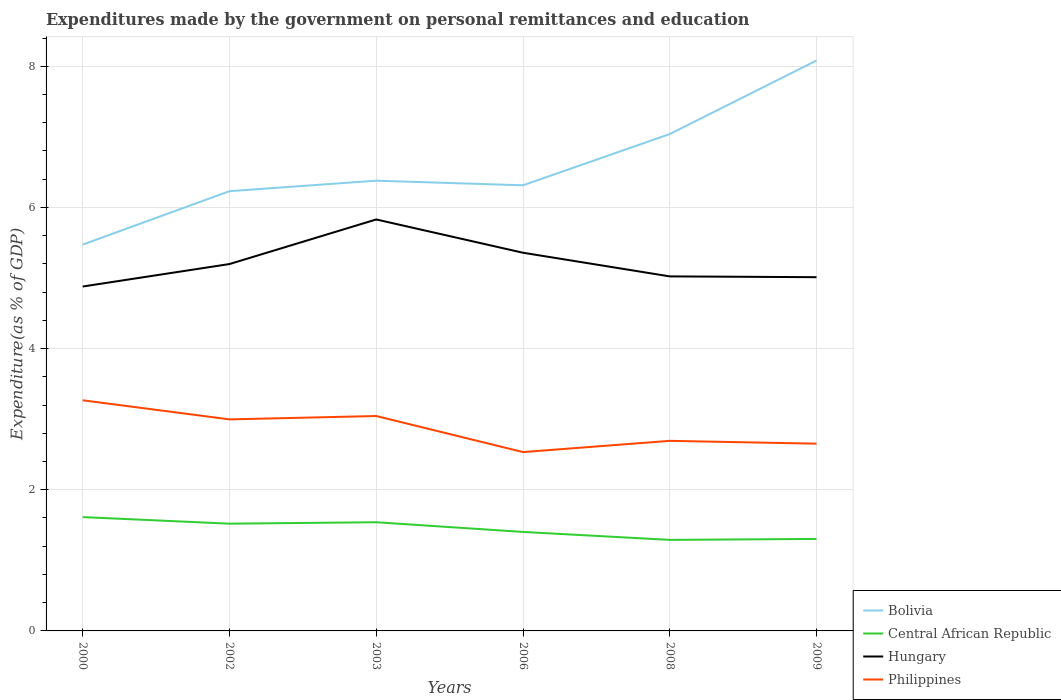Does the line corresponding to Philippines intersect with the line corresponding to Hungary?
Provide a succinct answer. No. Across all years, what is the maximum expenditures made by the government on personal remittances and education in Bolivia?
Your answer should be compact. 5.47. What is the total expenditures made by the government on personal remittances and education in Central African Republic in the graph?
Offer a very short reply. 0.31. What is the difference between the highest and the second highest expenditures made by the government on personal remittances and education in Central African Republic?
Give a very brief answer. 0.32. Is the expenditures made by the government on personal remittances and education in Central African Republic strictly greater than the expenditures made by the government on personal remittances and education in Bolivia over the years?
Offer a very short reply. Yes. How many lines are there?
Keep it short and to the point. 4. How many legend labels are there?
Your answer should be very brief. 4. What is the title of the graph?
Offer a very short reply. Expenditures made by the government on personal remittances and education. Does "Least developed countries" appear as one of the legend labels in the graph?
Offer a terse response. No. What is the label or title of the X-axis?
Offer a very short reply. Years. What is the label or title of the Y-axis?
Your answer should be compact. Expenditure(as % of GDP). What is the Expenditure(as % of GDP) of Bolivia in 2000?
Provide a short and direct response. 5.47. What is the Expenditure(as % of GDP) in Central African Republic in 2000?
Offer a terse response. 1.61. What is the Expenditure(as % of GDP) in Hungary in 2000?
Offer a very short reply. 4.88. What is the Expenditure(as % of GDP) in Philippines in 2000?
Your answer should be compact. 3.27. What is the Expenditure(as % of GDP) of Bolivia in 2002?
Keep it short and to the point. 6.23. What is the Expenditure(as % of GDP) of Central African Republic in 2002?
Give a very brief answer. 1.52. What is the Expenditure(as % of GDP) in Hungary in 2002?
Ensure brevity in your answer.  5.2. What is the Expenditure(as % of GDP) of Philippines in 2002?
Give a very brief answer. 3. What is the Expenditure(as % of GDP) of Bolivia in 2003?
Give a very brief answer. 6.38. What is the Expenditure(as % of GDP) of Central African Republic in 2003?
Your answer should be compact. 1.54. What is the Expenditure(as % of GDP) in Hungary in 2003?
Your answer should be very brief. 5.83. What is the Expenditure(as % of GDP) in Philippines in 2003?
Offer a very short reply. 3.04. What is the Expenditure(as % of GDP) in Bolivia in 2006?
Make the answer very short. 6.31. What is the Expenditure(as % of GDP) of Central African Republic in 2006?
Keep it short and to the point. 1.4. What is the Expenditure(as % of GDP) in Hungary in 2006?
Offer a terse response. 5.36. What is the Expenditure(as % of GDP) of Philippines in 2006?
Offer a terse response. 2.53. What is the Expenditure(as % of GDP) in Bolivia in 2008?
Ensure brevity in your answer.  7.04. What is the Expenditure(as % of GDP) of Central African Republic in 2008?
Give a very brief answer. 1.29. What is the Expenditure(as % of GDP) of Hungary in 2008?
Ensure brevity in your answer.  5.02. What is the Expenditure(as % of GDP) in Philippines in 2008?
Give a very brief answer. 2.69. What is the Expenditure(as % of GDP) of Bolivia in 2009?
Ensure brevity in your answer.  8.08. What is the Expenditure(as % of GDP) of Central African Republic in 2009?
Your answer should be very brief. 1.3. What is the Expenditure(as % of GDP) in Hungary in 2009?
Your answer should be very brief. 5.01. What is the Expenditure(as % of GDP) in Philippines in 2009?
Keep it short and to the point. 2.65. Across all years, what is the maximum Expenditure(as % of GDP) of Bolivia?
Ensure brevity in your answer.  8.08. Across all years, what is the maximum Expenditure(as % of GDP) of Central African Republic?
Your answer should be very brief. 1.61. Across all years, what is the maximum Expenditure(as % of GDP) in Hungary?
Your answer should be very brief. 5.83. Across all years, what is the maximum Expenditure(as % of GDP) of Philippines?
Offer a very short reply. 3.27. Across all years, what is the minimum Expenditure(as % of GDP) of Bolivia?
Provide a short and direct response. 5.47. Across all years, what is the minimum Expenditure(as % of GDP) in Central African Republic?
Ensure brevity in your answer.  1.29. Across all years, what is the minimum Expenditure(as % of GDP) of Hungary?
Make the answer very short. 4.88. Across all years, what is the minimum Expenditure(as % of GDP) of Philippines?
Provide a short and direct response. 2.53. What is the total Expenditure(as % of GDP) in Bolivia in the graph?
Offer a very short reply. 39.52. What is the total Expenditure(as % of GDP) in Central African Republic in the graph?
Your answer should be very brief. 8.67. What is the total Expenditure(as % of GDP) in Hungary in the graph?
Your answer should be compact. 31.3. What is the total Expenditure(as % of GDP) in Philippines in the graph?
Give a very brief answer. 17.19. What is the difference between the Expenditure(as % of GDP) in Bolivia in 2000 and that in 2002?
Your response must be concise. -0.76. What is the difference between the Expenditure(as % of GDP) of Central African Republic in 2000 and that in 2002?
Your response must be concise. 0.09. What is the difference between the Expenditure(as % of GDP) in Hungary in 2000 and that in 2002?
Provide a short and direct response. -0.32. What is the difference between the Expenditure(as % of GDP) in Philippines in 2000 and that in 2002?
Provide a short and direct response. 0.27. What is the difference between the Expenditure(as % of GDP) of Bolivia in 2000 and that in 2003?
Your response must be concise. -0.91. What is the difference between the Expenditure(as % of GDP) in Central African Republic in 2000 and that in 2003?
Provide a succinct answer. 0.07. What is the difference between the Expenditure(as % of GDP) of Hungary in 2000 and that in 2003?
Your answer should be compact. -0.95. What is the difference between the Expenditure(as % of GDP) in Philippines in 2000 and that in 2003?
Make the answer very short. 0.22. What is the difference between the Expenditure(as % of GDP) in Bolivia in 2000 and that in 2006?
Offer a very short reply. -0.84. What is the difference between the Expenditure(as % of GDP) in Central African Republic in 2000 and that in 2006?
Provide a succinct answer. 0.21. What is the difference between the Expenditure(as % of GDP) in Hungary in 2000 and that in 2006?
Make the answer very short. -0.48. What is the difference between the Expenditure(as % of GDP) of Philippines in 2000 and that in 2006?
Your response must be concise. 0.73. What is the difference between the Expenditure(as % of GDP) of Bolivia in 2000 and that in 2008?
Ensure brevity in your answer.  -1.57. What is the difference between the Expenditure(as % of GDP) in Central African Republic in 2000 and that in 2008?
Offer a very short reply. 0.32. What is the difference between the Expenditure(as % of GDP) in Hungary in 2000 and that in 2008?
Provide a short and direct response. -0.14. What is the difference between the Expenditure(as % of GDP) in Philippines in 2000 and that in 2008?
Provide a succinct answer. 0.57. What is the difference between the Expenditure(as % of GDP) in Bolivia in 2000 and that in 2009?
Provide a succinct answer. -2.61. What is the difference between the Expenditure(as % of GDP) of Central African Republic in 2000 and that in 2009?
Ensure brevity in your answer.  0.31. What is the difference between the Expenditure(as % of GDP) in Hungary in 2000 and that in 2009?
Provide a succinct answer. -0.13. What is the difference between the Expenditure(as % of GDP) of Philippines in 2000 and that in 2009?
Your response must be concise. 0.61. What is the difference between the Expenditure(as % of GDP) of Bolivia in 2002 and that in 2003?
Your response must be concise. -0.15. What is the difference between the Expenditure(as % of GDP) of Central African Republic in 2002 and that in 2003?
Your answer should be very brief. -0.02. What is the difference between the Expenditure(as % of GDP) in Hungary in 2002 and that in 2003?
Your answer should be very brief. -0.63. What is the difference between the Expenditure(as % of GDP) of Philippines in 2002 and that in 2003?
Your answer should be compact. -0.05. What is the difference between the Expenditure(as % of GDP) in Bolivia in 2002 and that in 2006?
Your response must be concise. -0.08. What is the difference between the Expenditure(as % of GDP) in Central African Republic in 2002 and that in 2006?
Give a very brief answer. 0.12. What is the difference between the Expenditure(as % of GDP) in Hungary in 2002 and that in 2006?
Your answer should be compact. -0.16. What is the difference between the Expenditure(as % of GDP) of Philippines in 2002 and that in 2006?
Give a very brief answer. 0.46. What is the difference between the Expenditure(as % of GDP) of Bolivia in 2002 and that in 2008?
Provide a short and direct response. -0.81. What is the difference between the Expenditure(as % of GDP) in Central African Republic in 2002 and that in 2008?
Offer a very short reply. 0.23. What is the difference between the Expenditure(as % of GDP) in Hungary in 2002 and that in 2008?
Offer a terse response. 0.17. What is the difference between the Expenditure(as % of GDP) in Philippines in 2002 and that in 2008?
Make the answer very short. 0.3. What is the difference between the Expenditure(as % of GDP) in Bolivia in 2002 and that in 2009?
Ensure brevity in your answer.  -1.85. What is the difference between the Expenditure(as % of GDP) in Central African Republic in 2002 and that in 2009?
Provide a short and direct response. 0.22. What is the difference between the Expenditure(as % of GDP) of Hungary in 2002 and that in 2009?
Provide a short and direct response. 0.19. What is the difference between the Expenditure(as % of GDP) in Philippines in 2002 and that in 2009?
Give a very brief answer. 0.34. What is the difference between the Expenditure(as % of GDP) in Bolivia in 2003 and that in 2006?
Keep it short and to the point. 0.07. What is the difference between the Expenditure(as % of GDP) of Central African Republic in 2003 and that in 2006?
Make the answer very short. 0.14. What is the difference between the Expenditure(as % of GDP) in Hungary in 2003 and that in 2006?
Provide a short and direct response. 0.47. What is the difference between the Expenditure(as % of GDP) of Philippines in 2003 and that in 2006?
Make the answer very short. 0.51. What is the difference between the Expenditure(as % of GDP) in Bolivia in 2003 and that in 2008?
Offer a very short reply. -0.66. What is the difference between the Expenditure(as % of GDP) in Central African Republic in 2003 and that in 2008?
Your answer should be compact. 0.25. What is the difference between the Expenditure(as % of GDP) in Hungary in 2003 and that in 2008?
Your answer should be compact. 0.81. What is the difference between the Expenditure(as % of GDP) in Philippines in 2003 and that in 2008?
Offer a terse response. 0.35. What is the difference between the Expenditure(as % of GDP) of Bolivia in 2003 and that in 2009?
Keep it short and to the point. -1.7. What is the difference between the Expenditure(as % of GDP) in Central African Republic in 2003 and that in 2009?
Your answer should be compact. 0.24. What is the difference between the Expenditure(as % of GDP) of Hungary in 2003 and that in 2009?
Give a very brief answer. 0.82. What is the difference between the Expenditure(as % of GDP) in Philippines in 2003 and that in 2009?
Make the answer very short. 0.39. What is the difference between the Expenditure(as % of GDP) in Bolivia in 2006 and that in 2008?
Ensure brevity in your answer.  -0.73. What is the difference between the Expenditure(as % of GDP) of Central African Republic in 2006 and that in 2008?
Keep it short and to the point. 0.11. What is the difference between the Expenditure(as % of GDP) of Hungary in 2006 and that in 2008?
Ensure brevity in your answer.  0.34. What is the difference between the Expenditure(as % of GDP) in Philippines in 2006 and that in 2008?
Offer a very short reply. -0.16. What is the difference between the Expenditure(as % of GDP) of Bolivia in 2006 and that in 2009?
Ensure brevity in your answer.  -1.77. What is the difference between the Expenditure(as % of GDP) of Central African Republic in 2006 and that in 2009?
Ensure brevity in your answer.  0.1. What is the difference between the Expenditure(as % of GDP) in Hungary in 2006 and that in 2009?
Your answer should be very brief. 0.35. What is the difference between the Expenditure(as % of GDP) in Philippines in 2006 and that in 2009?
Provide a short and direct response. -0.12. What is the difference between the Expenditure(as % of GDP) in Bolivia in 2008 and that in 2009?
Offer a terse response. -1.04. What is the difference between the Expenditure(as % of GDP) of Central African Republic in 2008 and that in 2009?
Ensure brevity in your answer.  -0.01. What is the difference between the Expenditure(as % of GDP) in Hungary in 2008 and that in 2009?
Your answer should be compact. 0.01. What is the difference between the Expenditure(as % of GDP) in Bolivia in 2000 and the Expenditure(as % of GDP) in Central African Republic in 2002?
Offer a terse response. 3.95. What is the difference between the Expenditure(as % of GDP) in Bolivia in 2000 and the Expenditure(as % of GDP) in Hungary in 2002?
Provide a short and direct response. 0.28. What is the difference between the Expenditure(as % of GDP) in Bolivia in 2000 and the Expenditure(as % of GDP) in Philippines in 2002?
Give a very brief answer. 2.48. What is the difference between the Expenditure(as % of GDP) of Central African Republic in 2000 and the Expenditure(as % of GDP) of Hungary in 2002?
Your answer should be compact. -3.59. What is the difference between the Expenditure(as % of GDP) in Central African Republic in 2000 and the Expenditure(as % of GDP) in Philippines in 2002?
Offer a very short reply. -1.38. What is the difference between the Expenditure(as % of GDP) of Hungary in 2000 and the Expenditure(as % of GDP) of Philippines in 2002?
Your answer should be very brief. 1.88. What is the difference between the Expenditure(as % of GDP) in Bolivia in 2000 and the Expenditure(as % of GDP) in Central African Republic in 2003?
Offer a very short reply. 3.93. What is the difference between the Expenditure(as % of GDP) of Bolivia in 2000 and the Expenditure(as % of GDP) of Hungary in 2003?
Offer a terse response. -0.36. What is the difference between the Expenditure(as % of GDP) in Bolivia in 2000 and the Expenditure(as % of GDP) in Philippines in 2003?
Your response must be concise. 2.43. What is the difference between the Expenditure(as % of GDP) of Central African Republic in 2000 and the Expenditure(as % of GDP) of Hungary in 2003?
Provide a succinct answer. -4.22. What is the difference between the Expenditure(as % of GDP) of Central African Republic in 2000 and the Expenditure(as % of GDP) of Philippines in 2003?
Your response must be concise. -1.43. What is the difference between the Expenditure(as % of GDP) in Hungary in 2000 and the Expenditure(as % of GDP) in Philippines in 2003?
Provide a succinct answer. 1.83. What is the difference between the Expenditure(as % of GDP) in Bolivia in 2000 and the Expenditure(as % of GDP) in Central African Republic in 2006?
Make the answer very short. 4.07. What is the difference between the Expenditure(as % of GDP) of Bolivia in 2000 and the Expenditure(as % of GDP) of Hungary in 2006?
Your answer should be compact. 0.12. What is the difference between the Expenditure(as % of GDP) of Bolivia in 2000 and the Expenditure(as % of GDP) of Philippines in 2006?
Provide a short and direct response. 2.94. What is the difference between the Expenditure(as % of GDP) in Central African Republic in 2000 and the Expenditure(as % of GDP) in Hungary in 2006?
Offer a terse response. -3.75. What is the difference between the Expenditure(as % of GDP) of Central African Republic in 2000 and the Expenditure(as % of GDP) of Philippines in 2006?
Your answer should be compact. -0.92. What is the difference between the Expenditure(as % of GDP) in Hungary in 2000 and the Expenditure(as % of GDP) in Philippines in 2006?
Your answer should be compact. 2.35. What is the difference between the Expenditure(as % of GDP) in Bolivia in 2000 and the Expenditure(as % of GDP) in Central African Republic in 2008?
Offer a very short reply. 4.18. What is the difference between the Expenditure(as % of GDP) of Bolivia in 2000 and the Expenditure(as % of GDP) of Hungary in 2008?
Give a very brief answer. 0.45. What is the difference between the Expenditure(as % of GDP) of Bolivia in 2000 and the Expenditure(as % of GDP) of Philippines in 2008?
Your response must be concise. 2.78. What is the difference between the Expenditure(as % of GDP) of Central African Republic in 2000 and the Expenditure(as % of GDP) of Hungary in 2008?
Make the answer very short. -3.41. What is the difference between the Expenditure(as % of GDP) in Central African Republic in 2000 and the Expenditure(as % of GDP) in Philippines in 2008?
Your answer should be compact. -1.08. What is the difference between the Expenditure(as % of GDP) of Hungary in 2000 and the Expenditure(as % of GDP) of Philippines in 2008?
Offer a very short reply. 2.19. What is the difference between the Expenditure(as % of GDP) in Bolivia in 2000 and the Expenditure(as % of GDP) in Central African Republic in 2009?
Keep it short and to the point. 4.17. What is the difference between the Expenditure(as % of GDP) in Bolivia in 2000 and the Expenditure(as % of GDP) in Hungary in 2009?
Give a very brief answer. 0.46. What is the difference between the Expenditure(as % of GDP) of Bolivia in 2000 and the Expenditure(as % of GDP) of Philippines in 2009?
Offer a terse response. 2.82. What is the difference between the Expenditure(as % of GDP) in Central African Republic in 2000 and the Expenditure(as % of GDP) in Hungary in 2009?
Your response must be concise. -3.4. What is the difference between the Expenditure(as % of GDP) of Central African Republic in 2000 and the Expenditure(as % of GDP) of Philippines in 2009?
Ensure brevity in your answer.  -1.04. What is the difference between the Expenditure(as % of GDP) in Hungary in 2000 and the Expenditure(as % of GDP) in Philippines in 2009?
Provide a short and direct response. 2.23. What is the difference between the Expenditure(as % of GDP) in Bolivia in 2002 and the Expenditure(as % of GDP) in Central African Republic in 2003?
Make the answer very short. 4.69. What is the difference between the Expenditure(as % of GDP) of Bolivia in 2002 and the Expenditure(as % of GDP) of Hungary in 2003?
Give a very brief answer. 0.4. What is the difference between the Expenditure(as % of GDP) of Bolivia in 2002 and the Expenditure(as % of GDP) of Philippines in 2003?
Your response must be concise. 3.19. What is the difference between the Expenditure(as % of GDP) in Central African Republic in 2002 and the Expenditure(as % of GDP) in Hungary in 2003?
Offer a terse response. -4.31. What is the difference between the Expenditure(as % of GDP) in Central African Republic in 2002 and the Expenditure(as % of GDP) in Philippines in 2003?
Provide a short and direct response. -1.53. What is the difference between the Expenditure(as % of GDP) in Hungary in 2002 and the Expenditure(as % of GDP) in Philippines in 2003?
Offer a very short reply. 2.15. What is the difference between the Expenditure(as % of GDP) of Bolivia in 2002 and the Expenditure(as % of GDP) of Central African Republic in 2006?
Your answer should be compact. 4.83. What is the difference between the Expenditure(as % of GDP) in Bolivia in 2002 and the Expenditure(as % of GDP) in Hungary in 2006?
Ensure brevity in your answer.  0.87. What is the difference between the Expenditure(as % of GDP) of Bolivia in 2002 and the Expenditure(as % of GDP) of Philippines in 2006?
Keep it short and to the point. 3.7. What is the difference between the Expenditure(as % of GDP) of Central African Republic in 2002 and the Expenditure(as % of GDP) of Hungary in 2006?
Your answer should be very brief. -3.84. What is the difference between the Expenditure(as % of GDP) of Central African Republic in 2002 and the Expenditure(as % of GDP) of Philippines in 2006?
Your answer should be very brief. -1.01. What is the difference between the Expenditure(as % of GDP) of Hungary in 2002 and the Expenditure(as % of GDP) of Philippines in 2006?
Provide a short and direct response. 2.66. What is the difference between the Expenditure(as % of GDP) in Bolivia in 2002 and the Expenditure(as % of GDP) in Central African Republic in 2008?
Provide a succinct answer. 4.94. What is the difference between the Expenditure(as % of GDP) in Bolivia in 2002 and the Expenditure(as % of GDP) in Hungary in 2008?
Your answer should be compact. 1.21. What is the difference between the Expenditure(as % of GDP) in Bolivia in 2002 and the Expenditure(as % of GDP) in Philippines in 2008?
Your answer should be compact. 3.54. What is the difference between the Expenditure(as % of GDP) in Central African Republic in 2002 and the Expenditure(as % of GDP) in Hungary in 2008?
Provide a succinct answer. -3.5. What is the difference between the Expenditure(as % of GDP) in Central African Republic in 2002 and the Expenditure(as % of GDP) in Philippines in 2008?
Provide a succinct answer. -1.17. What is the difference between the Expenditure(as % of GDP) of Hungary in 2002 and the Expenditure(as % of GDP) of Philippines in 2008?
Your answer should be compact. 2.5. What is the difference between the Expenditure(as % of GDP) of Bolivia in 2002 and the Expenditure(as % of GDP) of Central African Republic in 2009?
Offer a terse response. 4.93. What is the difference between the Expenditure(as % of GDP) in Bolivia in 2002 and the Expenditure(as % of GDP) in Hungary in 2009?
Make the answer very short. 1.22. What is the difference between the Expenditure(as % of GDP) in Bolivia in 2002 and the Expenditure(as % of GDP) in Philippines in 2009?
Provide a succinct answer. 3.58. What is the difference between the Expenditure(as % of GDP) of Central African Republic in 2002 and the Expenditure(as % of GDP) of Hungary in 2009?
Your answer should be very brief. -3.49. What is the difference between the Expenditure(as % of GDP) in Central African Republic in 2002 and the Expenditure(as % of GDP) in Philippines in 2009?
Keep it short and to the point. -1.13. What is the difference between the Expenditure(as % of GDP) in Hungary in 2002 and the Expenditure(as % of GDP) in Philippines in 2009?
Your answer should be very brief. 2.54. What is the difference between the Expenditure(as % of GDP) of Bolivia in 2003 and the Expenditure(as % of GDP) of Central African Republic in 2006?
Your answer should be compact. 4.98. What is the difference between the Expenditure(as % of GDP) in Bolivia in 2003 and the Expenditure(as % of GDP) in Hungary in 2006?
Provide a short and direct response. 1.02. What is the difference between the Expenditure(as % of GDP) of Bolivia in 2003 and the Expenditure(as % of GDP) of Philippines in 2006?
Your answer should be compact. 3.85. What is the difference between the Expenditure(as % of GDP) in Central African Republic in 2003 and the Expenditure(as % of GDP) in Hungary in 2006?
Make the answer very short. -3.82. What is the difference between the Expenditure(as % of GDP) of Central African Republic in 2003 and the Expenditure(as % of GDP) of Philippines in 2006?
Make the answer very short. -0.99. What is the difference between the Expenditure(as % of GDP) of Hungary in 2003 and the Expenditure(as % of GDP) of Philippines in 2006?
Keep it short and to the point. 3.3. What is the difference between the Expenditure(as % of GDP) of Bolivia in 2003 and the Expenditure(as % of GDP) of Central African Republic in 2008?
Make the answer very short. 5.09. What is the difference between the Expenditure(as % of GDP) in Bolivia in 2003 and the Expenditure(as % of GDP) in Hungary in 2008?
Give a very brief answer. 1.36. What is the difference between the Expenditure(as % of GDP) of Bolivia in 2003 and the Expenditure(as % of GDP) of Philippines in 2008?
Provide a short and direct response. 3.69. What is the difference between the Expenditure(as % of GDP) of Central African Republic in 2003 and the Expenditure(as % of GDP) of Hungary in 2008?
Give a very brief answer. -3.48. What is the difference between the Expenditure(as % of GDP) in Central African Republic in 2003 and the Expenditure(as % of GDP) in Philippines in 2008?
Ensure brevity in your answer.  -1.15. What is the difference between the Expenditure(as % of GDP) of Hungary in 2003 and the Expenditure(as % of GDP) of Philippines in 2008?
Provide a short and direct response. 3.14. What is the difference between the Expenditure(as % of GDP) in Bolivia in 2003 and the Expenditure(as % of GDP) in Central African Republic in 2009?
Provide a succinct answer. 5.08. What is the difference between the Expenditure(as % of GDP) in Bolivia in 2003 and the Expenditure(as % of GDP) in Hungary in 2009?
Keep it short and to the point. 1.37. What is the difference between the Expenditure(as % of GDP) of Bolivia in 2003 and the Expenditure(as % of GDP) of Philippines in 2009?
Your answer should be very brief. 3.73. What is the difference between the Expenditure(as % of GDP) in Central African Republic in 2003 and the Expenditure(as % of GDP) in Hungary in 2009?
Your answer should be very brief. -3.47. What is the difference between the Expenditure(as % of GDP) of Central African Republic in 2003 and the Expenditure(as % of GDP) of Philippines in 2009?
Your answer should be compact. -1.11. What is the difference between the Expenditure(as % of GDP) in Hungary in 2003 and the Expenditure(as % of GDP) in Philippines in 2009?
Keep it short and to the point. 3.18. What is the difference between the Expenditure(as % of GDP) in Bolivia in 2006 and the Expenditure(as % of GDP) in Central African Republic in 2008?
Provide a short and direct response. 5.02. What is the difference between the Expenditure(as % of GDP) of Bolivia in 2006 and the Expenditure(as % of GDP) of Hungary in 2008?
Offer a terse response. 1.29. What is the difference between the Expenditure(as % of GDP) in Bolivia in 2006 and the Expenditure(as % of GDP) in Philippines in 2008?
Your response must be concise. 3.62. What is the difference between the Expenditure(as % of GDP) of Central African Republic in 2006 and the Expenditure(as % of GDP) of Hungary in 2008?
Offer a very short reply. -3.62. What is the difference between the Expenditure(as % of GDP) of Central African Republic in 2006 and the Expenditure(as % of GDP) of Philippines in 2008?
Make the answer very short. -1.29. What is the difference between the Expenditure(as % of GDP) in Hungary in 2006 and the Expenditure(as % of GDP) in Philippines in 2008?
Give a very brief answer. 2.67. What is the difference between the Expenditure(as % of GDP) in Bolivia in 2006 and the Expenditure(as % of GDP) in Central African Republic in 2009?
Offer a very short reply. 5.01. What is the difference between the Expenditure(as % of GDP) in Bolivia in 2006 and the Expenditure(as % of GDP) in Hungary in 2009?
Offer a terse response. 1.3. What is the difference between the Expenditure(as % of GDP) of Bolivia in 2006 and the Expenditure(as % of GDP) of Philippines in 2009?
Your answer should be very brief. 3.66. What is the difference between the Expenditure(as % of GDP) in Central African Republic in 2006 and the Expenditure(as % of GDP) in Hungary in 2009?
Ensure brevity in your answer.  -3.61. What is the difference between the Expenditure(as % of GDP) in Central African Republic in 2006 and the Expenditure(as % of GDP) in Philippines in 2009?
Offer a very short reply. -1.25. What is the difference between the Expenditure(as % of GDP) of Hungary in 2006 and the Expenditure(as % of GDP) of Philippines in 2009?
Provide a short and direct response. 2.71. What is the difference between the Expenditure(as % of GDP) of Bolivia in 2008 and the Expenditure(as % of GDP) of Central African Republic in 2009?
Provide a succinct answer. 5.74. What is the difference between the Expenditure(as % of GDP) of Bolivia in 2008 and the Expenditure(as % of GDP) of Hungary in 2009?
Offer a terse response. 2.03. What is the difference between the Expenditure(as % of GDP) in Bolivia in 2008 and the Expenditure(as % of GDP) in Philippines in 2009?
Keep it short and to the point. 4.39. What is the difference between the Expenditure(as % of GDP) of Central African Republic in 2008 and the Expenditure(as % of GDP) of Hungary in 2009?
Keep it short and to the point. -3.72. What is the difference between the Expenditure(as % of GDP) of Central African Republic in 2008 and the Expenditure(as % of GDP) of Philippines in 2009?
Keep it short and to the point. -1.36. What is the difference between the Expenditure(as % of GDP) in Hungary in 2008 and the Expenditure(as % of GDP) in Philippines in 2009?
Your answer should be very brief. 2.37. What is the average Expenditure(as % of GDP) in Bolivia per year?
Your response must be concise. 6.59. What is the average Expenditure(as % of GDP) in Central African Republic per year?
Provide a succinct answer. 1.44. What is the average Expenditure(as % of GDP) in Hungary per year?
Offer a terse response. 5.22. What is the average Expenditure(as % of GDP) of Philippines per year?
Offer a very short reply. 2.86. In the year 2000, what is the difference between the Expenditure(as % of GDP) of Bolivia and Expenditure(as % of GDP) of Central African Republic?
Provide a succinct answer. 3.86. In the year 2000, what is the difference between the Expenditure(as % of GDP) in Bolivia and Expenditure(as % of GDP) in Hungary?
Provide a succinct answer. 0.59. In the year 2000, what is the difference between the Expenditure(as % of GDP) of Bolivia and Expenditure(as % of GDP) of Philippines?
Offer a very short reply. 2.21. In the year 2000, what is the difference between the Expenditure(as % of GDP) of Central African Republic and Expenditure(as % of GDP) of Hungary?
Make the answer very short. -3.27. In the year 2000, what is the difference between the Expenditure(as % of GDP) of Central African Republic and Expenditure(as % of GDP) of Philippines?
Give a very brief answer. -1.66. In the year 2000, what is the difference between the Expenditure(as % of GDP) in Hungary and Expenditure(as % of GDP) in Philippines?
Keep it short and to the point. 1.61. In the year 2002, what is the difference between the Expenditure(as % of GDP) of Bolivia and Expenditure(as % of GDP) of Central African Republic?
Keep it short and to the point. 4.71. In the year 2002, what is the difference between the Expenditure(as % of GDP) in Bolivia and Expenditure(as % of GDP) in Hungary?
Your answer should be very brief. 1.03. In the year 2002, what is the difference between the Expenditure(as % of GDP) of Bolivia and Expenditure(as % of GDP) of Philippines?
Your answer should be compact. 3.23. In the year 2002, what is the difference between the Expenditure(as % of GDP) in Central African Republic and Expenditure(as % of GDP) in Hungary?
Keep it short and to the point. -3.68. In the year 2002, what is the difference between the Expenditure(as % of GDP) of Central African Republic and Expenditure(as % of GDP) of Philippines?
Provide a short and direct response. -1.48. In the year 2002, what is the difference between the Expenditure(as % of GDP) of Hungary and Expenditure(as % of GDP) of Philippines?
Your response must be concise. 2.2. In the year 2003, what is the difference between the Expenditure(as % of GDP) of Bolivia and Expenditure(as % of GDP) of Central African Republic?
Make the answer very short. 4.84. In the year 2003, what is the difference between the Expenditure(as % of GDP) in Bolivia and Expenditure(as % of GDP) in Hungary?
Provide a succinct answer. 0.55. In the year 2003, what is the difference between the Expenditure(as % of GDP) of Bolivia and Expenditure(as % of GDP) of Philippines?
Offer a terse response. 3.33. In the year 2003, what is the difference between the Expenditure(as % of GDP) in Central African Republic and Expenditure(as % of GDP) in Hungary?
Your answer should be very brief. -4.29. In the year 2003, what is the difference between the Expenditure(as % of GDP) of Central African Republic and Expenditure(as % of GDP) of Philippines?
Make the answer very short. -1.5. In the year 2003, what is the difference between the Expenditure(as % of GDP) in Hungary and Expenditure(as % of GDP) in Philippines?
Give a very brief answer. 2.79. In the year 2006, what is the difference between the Expenditure(as % of GDP) of Bolivia and Expenditure(as % of GDP) of Central African Republic?
Your answer should be compact. 4.91. In the year 2006, what is the difference between the Expenditure(as % of GDP) in Bolivia and Expenditure(as % of GDP) in Hungary?
Your answer should be compact. 0.96. In the year 2006, what is the difference between the Expenditure(as % of GDP) of Bolivia and Expenditure(as % of GDP) of Philippines?
Your response must be concise. 3.78. In the year 2006, what is the difference between the Expenditure(as % of GDP) of Central African Republic and Expenditure(as % of GDP) of Hungary?
Ensure brevity in your answer.  -3.96. In the year 2006, what is the difference between the Expenditure(as % of GDP) in Central African Republic and Expenditure(as % of GDP) in Philippines?
Provide a short and direct response. -1.13. In the year 2006, what is the difference between the Expenditure(as % of GDP) of Hungary and Expenditure(as % of GDP) of Philippines?
Ensure brevity in your answer.  2.82. In the year 2008, what is the difference between the Expenditure(as % of GDP) in Bolivia and Expenditure(as % of GDP) in Central African Republic?
Ensure brevity in your answer.  5.75. In the year 2008, what is the difference between the Expenditure(as % of GDP) of Bolivia and Expenditure(as % of GDP) of Hungary?
Offer a very short reply. 2.02. In the year 2008, what is the difference between the Expenditure(as % of GDP) in Bolivia and Expenditure(as % of GDP) in Philippines?
Give a very brief answer. 4.35. In the year 2008, what is the difference between the Expenditure(as % of GDP) in Central African Republic and Expenditure(as % of GDP) in Hungary?
Your response must be concise. -3.73. In the year 2008, what is the difference between the Expenditure(as % of GDP) in Central African Republic and Expenditure(as % of GDP) in Philippines?
Your response must be concise. -1.4. In the year 2008, what is the difference between the Expenditure(as % of GDP) in Hungary and Expenditure(as % of GDP) in Philippines?
Your answer should be very brief. 2.33. In the year 2009, what is the difference between the Expenditure(as % of GDP) in Bolivia and Expenditure(as % of GDP) in Central African Republic?
Your answer should be compact. 6.78. In the year 2009, what is the difference between the Expenditure(as % of GDP) in Bolivia and Expenditure(as % of GDP) in Hungary?
Give a very brief answer. 3.07. In the year 2009, what is the difference between the Expenditure(as % of GDP) in Bolivia and Expenditure(as % of GDP) in Philippines?
Your answer should be compact. 5.43. In the year 2009, what is the difference between the Expenditure(as % of GDP) in Central African Republic and Expenditure(as % of GDP) in Hungary?
Keep it short and to the point. -3.71. In the year 2009, what is the difference between the Expenditure(as % of GDP) of Central African Republic and Expenditure(as % of GDP) of Philippines?
Keep it short and to the point. -1.35. In the year 2009, what is the difference between the Expenditure(as % of GDP) in Hungary and Expenditure(as % of GDP) in Philippines?
Ensure brevity in your answer.  2.36. What is the ratio of the Expenditure(as % of GDP) of Bolivia in 2000 to that in 2002?
Make the answer very short. 0.88. What is the ratio of the Expenditure(as % of GDP) of Central African Republic in 2000 to that in 2002?
Give a very brief answer. 1.06. What is the ratio of the Expenditure(as % of GDP) in Hungary in 2000 to that in 2002?
Offer a very short reply. 0.94. What is the ratio of the Expenditure(as % of GDP) of Philippines in 2000 to that in 2002?
Make the answer very short. 1.09. What is the ratio of the Expenditure(as % of GDP) of Bolivia in 2000 to that in 2003?
Make the answer very short. 0.86. What is the ratio of the Expenditure(as % of GDP) of Central African Republic in 2000 to that in 2003?
Your answer should be very brief. 1.05. What is the ratio of the Expenditure(as % of GDP) of Hungary in 2000 to that in 2003?
Give a very brief answer. 0.84. What is the ratio of the Expenditure(as % of GDP) of Philippines in 2000 to that in 2003?
Provide a short and direct response. 1.07. What is the ratio of the Expenditure(as % of GDP) of Bolivia in 2000 to that in 2006?
Give a very brief answer. 0.87. What is the ratio of the Expenditure(as % of GDP) of Central African Republic in 2000 to that in 2006?
Provide a short and direct response. 1.15. What is the ratio of the Expenditure(as % of GDP) in Hungary in 2000 to that in 2006?
Provide a short and direct response. 0.91. What is the ratio of the Expenditure(as % of GDP) of Philippines in 2000 to that in 2006?
Your response must be concise. 1.29. What is the ratio of the Expenditure(as % of GDP) of Bolivia in 2000 to that in 2008?
Provide a succinct answer. 0.78. What is the ratio of the Expenditure(as % of GDP) in Central African Republic in 2000 to that in 2008?
Your response must be concise. 1.25. What is the ratio of the Expenditure(as % of GDP) of Hungary in 2000 to that in 2008?
Your response must be concise. 0.97. What is the ratio of the Expenditure(as % of GDP) of Philippines in 2000 to that in 2008?
Provide a short and direct response. 1.21. What is the ratio of the Expenditure(as % of GDP) in Bolivia in 2000 to that in 2009?
Your response must be concise. 0.68. What is the ratio of the Expenditure(as % of GDP) in Central African Republic in 2000 to that in 2009?
Your answer should be very brief. 1.24. What is the ratio of the Expenditure(as % of GDP) in Hungary in 2000 to that in 2009?
Your response must be concise. 0.97. What is the ratio of the Expenditure(as % of GDP) in Philippines in 2000 to that in 2009?
Ensure brevity in your answer.  1.23. What is the ratio of the Expenditure(as % of GDP) in Bolivia in 2002 to that in 2003?
Your answer should be compact. 0.98. What is the ratio of the Expenditure(as % of GDP) of Central African Republic in 2002 to that in 2003?
Make the answer very short. 0.99. What is the ratio of the Expenditure(as % of GDP) in Hungary in 2002 to that in 2003?
Keep it short and to the point. 0.89. What is the ratio of the Expenditure(as % of GDP) of Philippines in 2002 to that in 2003?
Your response must be concise. 0.98. What is the ratio of the Expenditure(as % of GDP) of Central African Republic in 2002 to that in 2006?
Your response must be concise. 1.08. What is the ratio of the Expenditure(as % of GDP) in Hungary in 2002 to that in 2006?
Ensure brevity in your answer.  0.97. What is the ratio of the Expenditure(as % of GDP) of Philippines in 2002 to that in 2006?
Your response must be concise. 1.18. What is the ratio of the Expenditure(as % of GDP) in Bolivia in 2002 to that in 2008?
Offer a terse response. 0.89. What is the ratio of the Expenditure(as % of GDP) in Central African Republic in 2002 to that in 2008?
Ensure brevity in your answer.  1.18. What is the ratio of the Expenditure(as % of GDP) in Hungary in 2002 to that in 2008?
Offer a terse response. 1.03. What is the ratio of the Expenditure(as % of GDP) of Philippines in 2002 to that in 2008?
Offer a very short reply. 1.11. What is the ratio of the Expenditure(as % of GDP) in Bolivia in 2002 to that in 2009?
Make the answer very short. 0.77. What is the ratio of the Expenditure(as % of GDP) in Central African Republic in 2002 to that in 2009?
Provide a succinct answer. 1.17. What is the ratio of the Expenditure(as % of GDP) in Hungary in 2002 to that in 2009?
Make the answer very short. 1.04. What is the ratio of the Expenditure(as % of GDP) of Philippines in 2002 to that in 2009?
Provide a succinct answer. 1.13. What is the ratio of the Expenditure(as % of GDP) of Bolivia in 2003 to that in 2006?
Ensure brevity in your answer.  1.01. What is the ratio of the Expenditure(as % of GDP) of Central African Republic in 2003 to that in 2006?
Offer a very short reply. 1.1. What is the ratio of the Expenditure(as % of GDP) of Hungary in 2003 to that in 2006?
Your answer should be compact. 1.09. What is the ratio of the Expenditure(as % of GDP) of Philippines in 2003 to that in 2006?
Your answer should be compact. 1.2. What is the ratio of the Expenditure(as % of GDP) of Bolivia in 2003 to that in 2008?
Provide a succinct answer. 0.91. What is the ratio of the Expenditure(as % of GDP) in Central African Republic in 2003 to that in 2008?
Your answer should be compact. 1.19. What is the ratio of the Expenditure(as % of GDP) in Hungary in 2003 to that in 2008?
Offer a very short reply. 1.16. What is the ratio of the Expenditure(as % of GDP) in Philippines in 2003 to that in 2008?
Your answer should be very brief. 1.13. What is the ratio of the Expenditure(as % of GDP) in Bolivia in 2003 to that in 2009?
Your answer should be compact. 0.79. What is the ratio of the Expenditure(as % of GDP) of Central African Republic in 2003 to that in 2009?
Your answer should be compact. 1.18. What is the ratio of the Expenditure(as % of GDP) of Hungary in 2003 to that in 2009?
Keep it short and to the point. 1.16. What is the ratio of the Expenditure(as % of GDP) in Philippines in 2003 to that in 2009?
Make the answer very short. 1.15. What is the ratio of the Expenditure(as % of GDP) of Bolivia in 2006 to that in 2008?
Provide a short and direct response. 0.9. What is the ratio of the Expenditure(as % of GDP) in Central African Republic in 2006 to that in 2008?
Provide a short and direct response. 1.09. What is the ratio of the Expenditure(as % of GDP) in Hungary in 2006 to that in 2008?
Offer a terse response. 1.07. What is the ratio of the Expenditure(as % of GDP) of Philippines in 2006 to that in 2008?
Your answer should be compact. 0.94. What is the ratio of the Expenditure(as % of GDP) of Bolivia in 2006 to that in 2009?
Provide a succinct answer. 0.78. What is the ratio of the Expenditure(as % of GDP) of Central African Republic in 2006 to that in 2009?
Provide a succinct answer. 1.08. What is the ratio of the Expenditure(as % of GDP) in Hungary in 2006 to that in 2009?
Keep it short and to the point. 1.07. What is the ratio of the Expenditure(as % of GDP) in Philippines in 2006 to that in 2009?
Keep it short and to the point. 0.96. What is the ratio of the Expenditure(as % of GDP) of Bolivia in 2008 to that in 2009?
Make the answer very short. 0.87. What is the ratio of the Expenditure(as % of GDP) of Philippines in 2008 to that in 2009?
Give a very brief answer. 1.02. What is the difference between the highest and the second highest Expenditure(as % of GDP) in Bolivia?
Offer a terse response. 1.04. What is the difference between the highest and the second highest Expenditure(as % of GDP) of Central African Republic?
Your answer should be compact. 0.07. What is the difference between the highest and the second highest Expenditure(as % of GDP) in Hungary?
Keep it short and to the point. 0.47. What is the difference between the highest and the second highest Expenditure(as % of GDP) in Philippines?
Your response must be concise. 0.22. What is the difference between the highest and the lowest Expenditure(as % of GDP) in Bolivia?
Provide a succinct answer. 2.61. What is the difference between the highest and the lowest Expenditure(as % of GDP) of Central African Republic?
Make the answer very short. 0.32. What is the difference between the highest and the lowest Expenditure(as % of GDP) of Hungary?
Your answer should be compact. 0.95. What is the difference between the highest and the lowest Expenditure(as % of GDP) of Philippines?
Your answer should be compact. 0.73. 